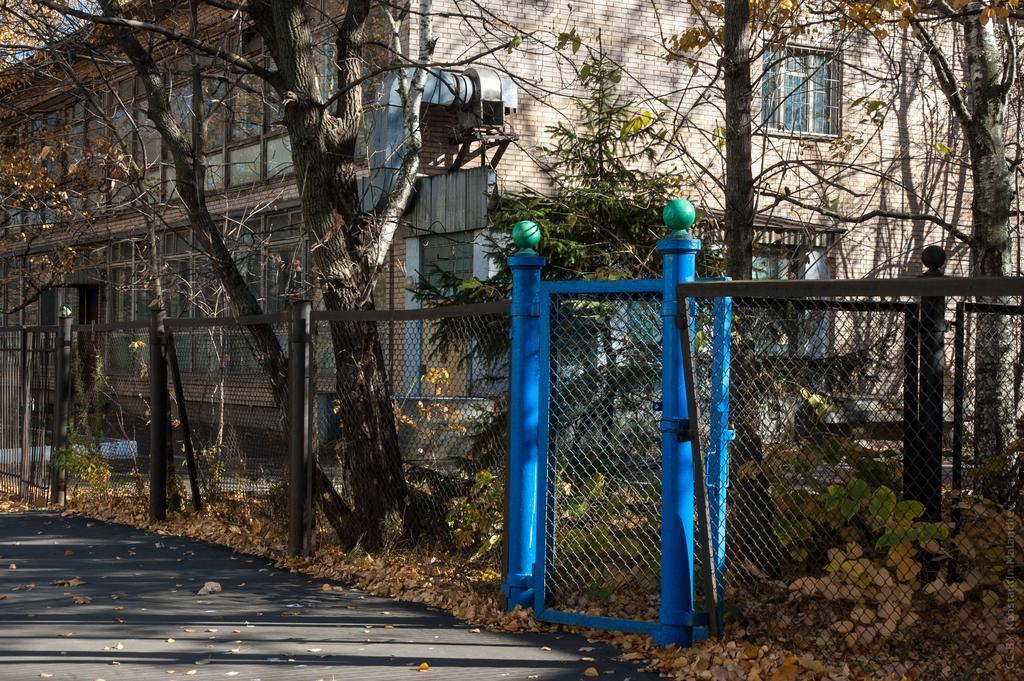In one or two sentences, can you explain what this image depicts? At the bottom of the image there is a road. Beside the road there is fencing with mesh and poles. And also there is a gate. On the ground there are leaves. Behind the fencing there are trees. And also there is a building with walls, windows, doors and a chimney. 